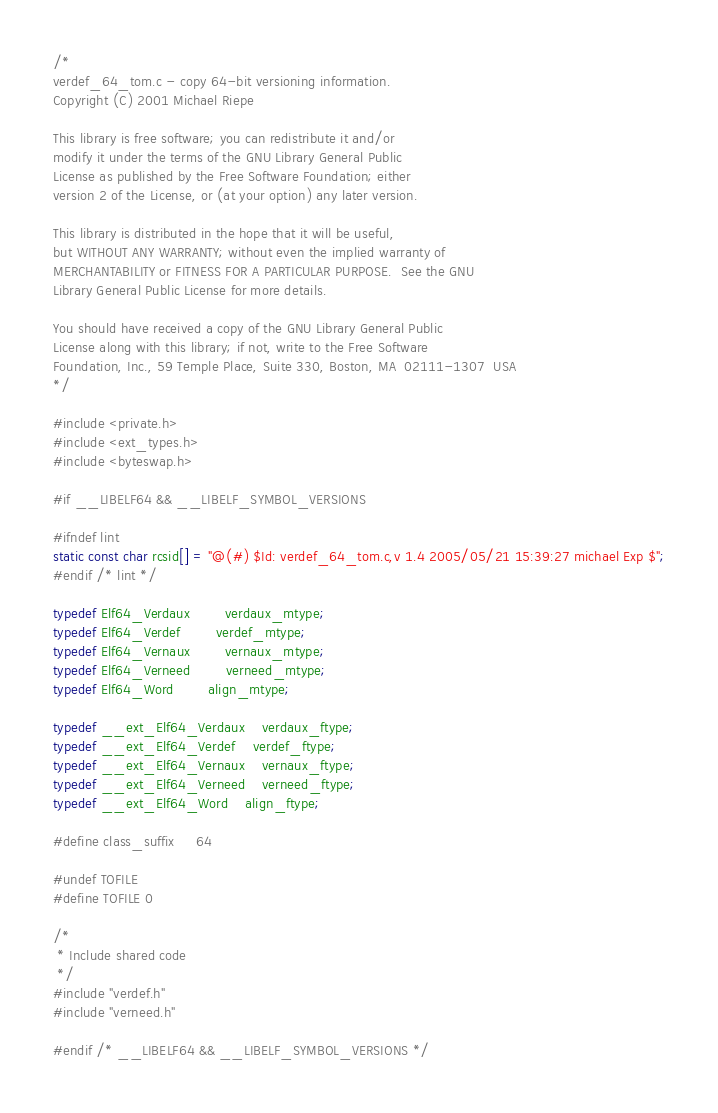<code> <loc_0><loc_0><loc_500><loc_500><_C_>/*
verdef_64_tom.c - copy 64-bit versioning information.
Copyright (C) 2001 Michael Riepe

This library is free software; you can redistribute it and/or
modify it under the terms of the GNU Library General Public
License as published by the Free Software Foundation; either
version 2 of the License, or (at your option) any later version.

This library is distributed in the hope that it will be useful,
but WITHOUT ANY WARRANTY; without even the implied warranty of
MERCHANTABILITY or FITNESS FOR A PARTICULAR PURPOSE.  See the GNU
Library General Public License for more details.

You should have received a copy of the GNU Library General Public
License along with this library; if not, write to the Free Software
Foundation, Inc., 59 Temple Place, Suite 330, Boston, MA  02111-1307  USA
*/

#include <private.h>
#include <ext_types.h>
#include <byteswap.h>

#if __LIBELF64 && __LIBELF_SYMBOL_VERSIONS

#ifndef lint
static const char rcsid[] = "@(#) $Id: verdef_64_tom.c,v 1.4 2005/05/21 15:39:27 michael Exp $";
#endif /* lint */

typedef Elf64_Verdaux		verdaux_mtype;
typedef Elf64_Verdef		verdef_mtype;
typedef Elf64_Vernaux		vernaux_mtype;
typedef Elf64_Verneed		verneed_mtype;
typedef Elf64_Word		align_mtype;

typedef __ext_Elf64_Verdaux	verdaux_ftype;
typedef __ext_Elf64_Verdef	verdef_ftype;
typedef __ext_Elf64_Vernaux	vernaux_ftype;
typedef __ext_Elf64_Verneed	verneed_ftype;
typedef __ext_Elf64_Word	align_ftype;

#define class_suffix		64

#undef TOFILE
#define TOFILE 0

/*
 * Include shared code
 */
#include "verdef.h"
#include "verneed.h"

#endif /* __LIBELF64 && __LIBELF_SYMBOL_VERSIONS */
</code> 